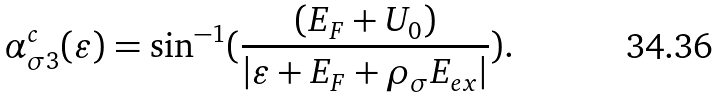<formula> <loc_0><loc_0><loc_500><loc_500>\alpha _ { \sigma 3 } ^ { c } ( \varepsilon ) = \sin ^ { - 1 } ( \frac { ( E _ { F } + U _ { 0 } ) } { | \varepsilon + E _ { F } + \rho _ { \sigma } E _ { e x } | } ) .</formula> 